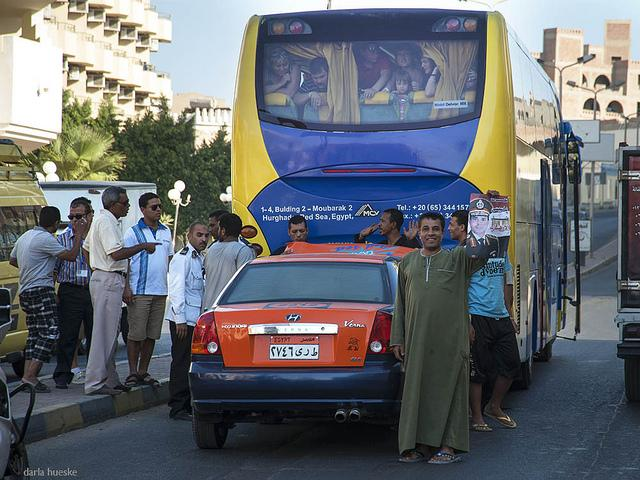What do those gathered look at here? bus 